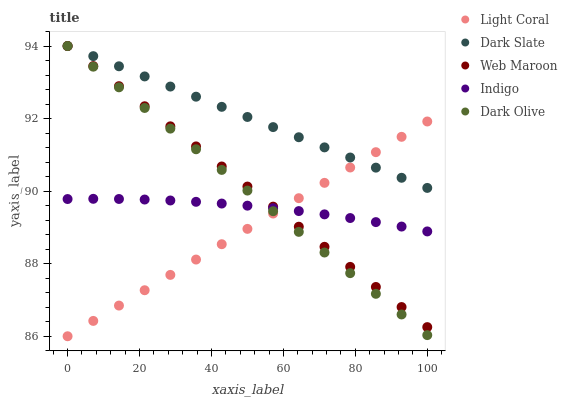Does Light Coral have the minimum area under the curve?
Answer yes or no. Yes. Does Dark Slate have the maximum area under the curve?
Answer yes or no. Yes. Does Dark Olive have the minimum area under the curve?
Answer yes or no. No. Does Dark Olive have the maximum area under the curve?
Answer yes or no. No. Is Light Coral the smoothest?
Answer yes or no. Yes. Is Indigo the roughest?
Answer yes or no. Yes. Is Dark Slate the smoothest?
Answer yes or no. No. Is Dark Slate the roughest?
Answer yes or no. No. Does Light Coral have the lowest value?
Answer yes or no. Yes. Does Dark Olive have the lowest value?
Answer yes or no. No. Does Web Maroon have the highest value?
Answer yes or no. Yes. Does Indigo have the highest value?
Answer yes or no. No. Is Indigo less than Dark Slate?
Answer yes or no. Yes. Is Dark Slate greater than Indigo?
Answer yes or no. Yes. Does Indigo intersect Dark Olive?
Answer yes or no. Yes. Is Indigo less than Dark Olive?
Answer yes or no. No. Is Indigo greater than Dark Olive?
Answer yes or no. No. Does Indigo intersect Dark Slate?
Answer yes or no. No. 